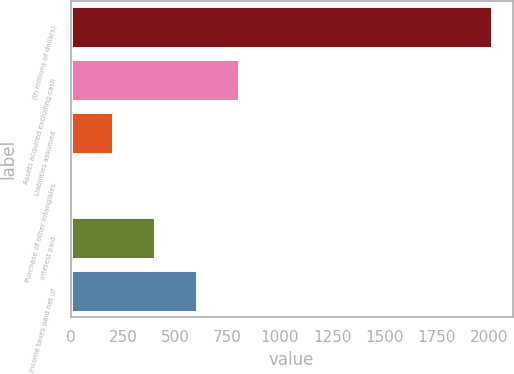Convert chart. <chart><loc_0><loc_0><loc_500><loc_500><bar_chart><fcel>(In millions of dollars)<fcel>Assets acquired excluding cash<fcel>Liabilities assumed<fcel>Purchase of other intangibles<fcel>Interest paid<fcel>Income taxes paid net of<nl><fcel>2012<fcel>806.6<fcel>203.9<fcel>3<fcel>404.8<fcel>605.7<nl></chart> 